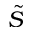<formula> <loc_0><loc_0><loc_500><loc_500>\tilde { S }</formula> 